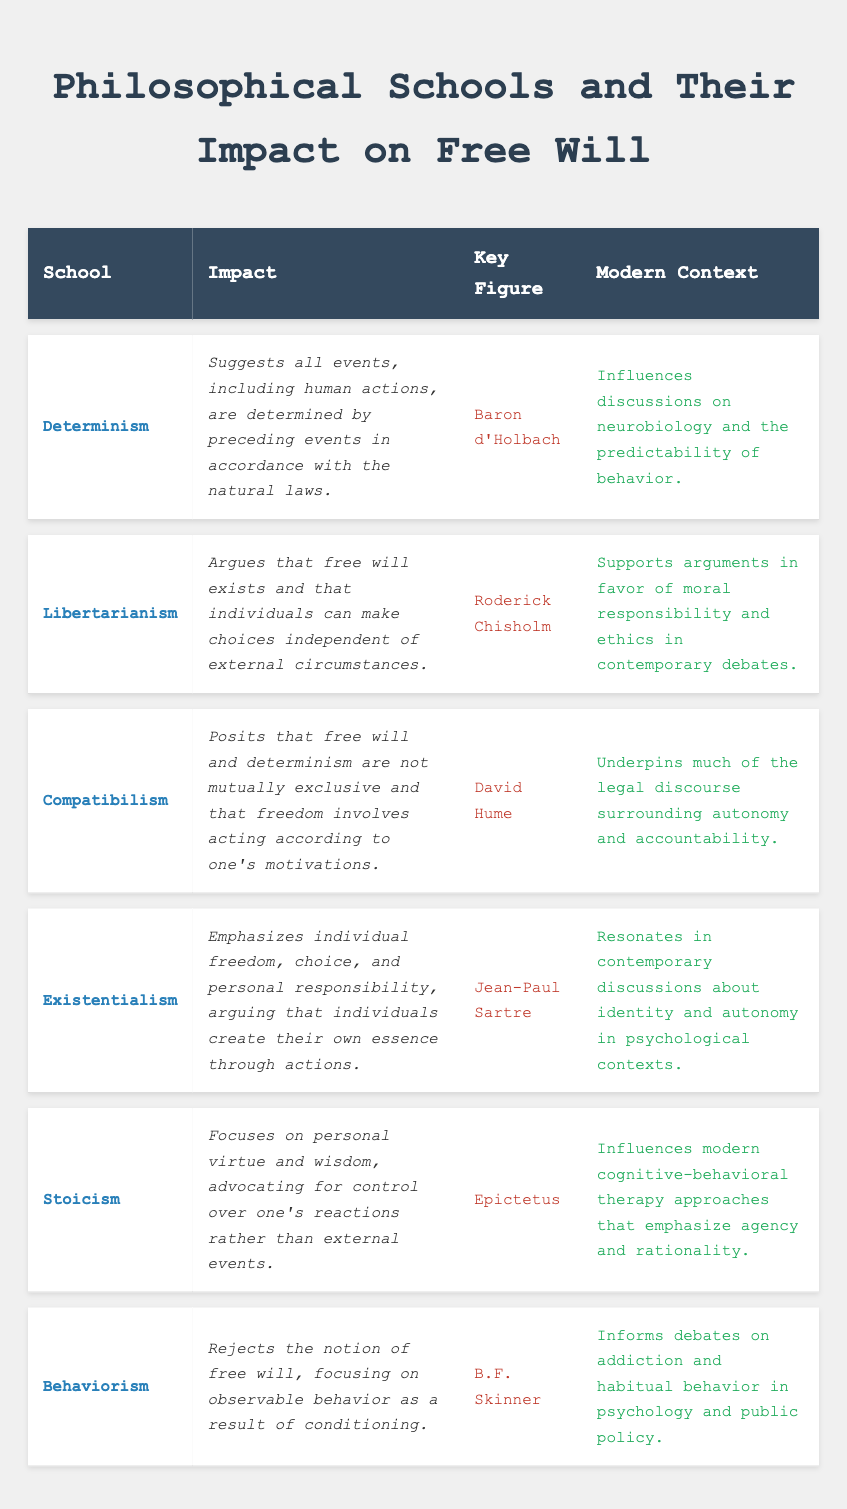What philosophical school argues for the existence of free will? The philosophical school that argues for the existence of free will is Libertarianism, as stated in the table.
Answer: Libertarianism Who is the key figure associated with Compatibilism? The table lists David Hume as the key figure associated with Compatibilism.
Answer: David Hume Which school of thought emphasizes individual freedom and personal responsibility? Existentialism is the philosophical school that emphasizes individual freedom and personal responsibility, according to the information in the table.
Answer: Existentialism Does Behaviorism accept the notion of free will? The table indicates that Behaviorism rejects the notion of free will, focusing instead on observable behavior.
Answer: No What is the impact of Stoicism on modern therapy approaches? The impact of Stoicism on modern therapy is that it influences cognitive-behavioral therapy approaches, which emphasize agency and rationality, as stated in the table.
Answer: Cognitive-behavioral therapy How many schools in the table reject the notion of free will? The table lists two schools that reject the notion of free will: Determinism and Behaviorism. Therefore, there are 2 schools that reject free will.
Answer: 2 Which philosophical school discusses the relationship between free will and determinism? Compatibilism discusses the relationship between free will and determinism, as it posits that they are not mutually exclusive according to the table.
Answer: Compatibilism What is the modern context attributed to Libertarianism? The modern context attributed to Libertarianism involves supporting arguments for moral responsibility and ethics in contemporary debates, as indicated in the table.
Answer: Moral responsibility and ethics debates Which key figure is linked to the impact of Existentialism in modern discussions? Jean-Paul Sartre is the key figure linked to the impact of Existentialism in modern discussions about identity and autonomy, according to the table.
Answer: Jean-Paul Sartre Which school has the most pessimistic view on free will, and who is its key figure? The school with the most pessimistic view on free will is Behaviorism, and its key figure is B.F. Skinner, as detailed in the table.
Answer: Behaviorism, B.F. Skinner 